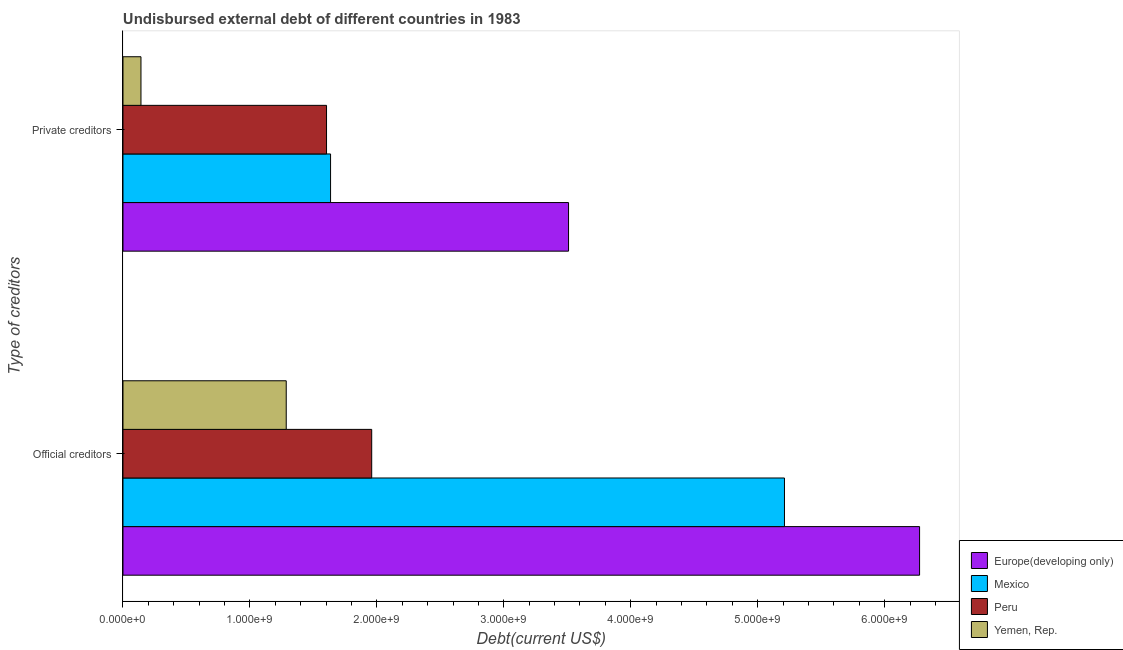What is the label of the 1st group of bars from the top?
Ensure brevity in your answer.  Private creditors. What is the undisbursed external debt of official creditors in Yemen, Rep.?
Offer a very short reply. 1.29e+09. Across all countries, what is the maximum undisbursed external debt of official creditors?
Make the answer very short. 6.28e+09. Across all countries, what is the minimum undisbursed external debt of official creditors?
Your response must be concise. 1.29e+09. In which country was the undisbursed external debt of private creditors maximum?
Your answer should be compact. Europe(developing only). In which country was the undisbursed external debt of private creditors minimum?
Give a very brief answer. Yemen, Rep. What is the total undisbursed external debt of official creditors in the graph?
Ensure brevity in your answer.  1.47e+1. What is the difference between the undisbursed external debt of private creditors in Mexico and that in Peru?
Your answer should be very brief. 3.18e+07. What is the difference between the undisbursed external debt of private creditors in Mexico and the undisbursed external debt of official creditors in Yemen, Rep.?
Give a very brief answer. 3.49e+08. What is the average undisbursed external debt of official creditors per country?
Offer a terse response. 3.68e+09. What is the difference between the undisbursed external debt of official creditors and undisbursed external debt of private creditors in Yemen, Rep.?
Your answer should be very brief. 1.14e+09. In how many countries, is the undisbursed external debt of official creditors greater than 5800000000 US$?
Provide a short and direct response. 1. What is the ratio of the undisbursed external debt of private creditors in Yemen, Rep. to that in Mexico?
Your answer should be very brief. 0.09. Is the undisbursed external debt of private creditors in Peru less than that in Mexico?
Provide a succinct answer. Yes. In how many countries, is the undisbursed external debt of official creditors greater than the average undisbursed external debt of official creditors taken over all countries?
Your answer should be compact. 2. What does the 4th bar from the top in Private creditors represents?
Offer a terse response. Europe(developing only). Are all the bars in the graph horizontal?
Your response must be concise. Yes. Are the values on the major ticks of X-axis written in scientific E-notation?
Provide a succinct answer. Yes. Does the graph contain any zero values?
Your answer should be compact. No. Where does the legend appear in the graph?
Offer a very short reply. Bottom right. How many legend labels are there?
Provide a short and direct response. 4. How are the legend labels stacked?
Provide a short and direct response. Vertical. What is the title of the graph?
Offer a terse response. Undisbursed external debt of different countries in 1983. Does "Bahamas" appear as one of the legend labels in the graph?
Offer a very short reply. No. What is the label or title of the X-axis?
Your answer should be compact. Debt(current US$). What is the label or title of the Y-axis?
Offer a very short reply. Type of creditors. What is the Debt(current US$) in Europe(developing only) in Official creditors?
Your answer should be compact. 6.28e+09. What is the Debt(current US$) in Mexico in Official creditors?
Offer a terse response. 5.21e+09. What is the Debt(current US$) in Peru in Official creditors?
Make the answer very short. 1.96e+09. What is the Debt(current US$) in Yemen, Rep. in Official creditors?
Your answer should be very brief. 1.29e+09. What is the Debt(current US$) of Europe(developing only) in Private creditors?
Your response must be concise. 3.51e+09. What is the Debt(current US$) of Mexico in Private creditors?
Your answer should be compact. 1.64e+09. What is the Debt(current US$) in Peru in Private creditors?
Offer a terse response. 1.60e+09. What is the Debt(current US$) of Yemen, Rep. in Private creditors?
Give a very brief answer. 1.42e+08. Across all Type of creditors, what is the maximum Debt(current US$) in Europe(developing only)?
Offer a very short reply. 6.28e+09. Across all Type of creditors, what is the maximum Debt(current US$) of Mexico?
Give a very brief answer. 5.21e+09. Across all Type of creditors, what is the maximum Debt(current US$) of Peru?
Make the answer very short. 1.96e+09. Across all Type of creditors, what is the maximum Debt(current US$) in Yemen, Rep.?
Ensure brevity in your answer.  1.29e+09. Across all Type of creditors, what is the minimum Debt(current US$) in Europe(developing only)?
Provide a succinct answer. 3.51e+09. Across all Type of creditors, what is the minimum Debt(current US$) of Mexico?
Provide a short and direct response. 1.64e+09. Across all Type of creditors, what is the minimum Debt(current US$) in Peru?
Provide a short and direct response. 1.60e+09. Across all Type of creditors, what is the minimum Debt(current US$) of Yemen, Rep.?
Ensure brevity in your answer.  1.42e+08. What is the total Debt(current US$) in Europe(developing only) in the graph?
Offer a terse response. 9.79e+09. What is the total Debt(current US$) in Mexico in the graph?
Provide a succinct answer. 6.85e+09. What is the total Debt(current US$) in Peru in the graph?
Keep it short and to the point. 3.56e+09. What is the total Debt(current US$) of Yemen, Rep. in the graph?
Provide a short and direct response. 1.43e+09. What is the difference between the Debt(current US$) in Europe(developing only) in Official creditors and that in Private creditors?
Provide a short and direct response. 2.77e+09. What is the difference between the Debt(current US$) in Mexico in Official creditors and that in Private creditors?
Your answer should be very brief. 3.58e+09. What is the difference between the Debt(current US$) of Peru in Official creditors and that in Private creditors?
Ensure brevity in your answer.  3.56e+08. What is the difference between the Debt(current US$) of Yemen, Rep. in Official creditors and that in Private creditors?
Ensure brevity in your answer.  1.14e+09. What is the difference between the Debt(current US$) in Europe(developing only) in Official creditors and the Debt(current US$) in Mexico in Private creditors?
Provide a succinct answer. 4.64e+09. What is the difference between the Debt(current US$) of Europe(developing only) in Official creditors and the Debt(current US$) of Peru in Private creditors?
Your response must be concise. 4.67e+09. What is the difference between the Debt(current US$) in Europe(developing only) in Official creditors and the Debt(current US$) in Yemen, Rep. in Private creditors?
Your answer should be very brief. 6.13e+09. What is the difference between the Debt(current US$) of Mexico in Official creditors and the Debt(current US$) of Peru in Private creditors?
Provide a short and direct response. 3.61e+09. What is the difference between the Debt(current US$) of Mexico in Official creditors and the Debt(current US$) of Yemen, Rep. in Private creditors?
Give a very brief answer. 5.07e+09. What is the difference between the Debt(current US$) in Peru in Official creditors and the Debt(current US$) in Yemen, Rep. in Private creditors?
Make the answer very short. 1.82e+09. What is the average Debt(current US$) in Europe(developing only) per Type of creditors?
Keep it short and to the point. 4.89e+09. What is the average Debt(current US$) in Mexico per Type of creditors?
Your response must be concise. 3.42e+09. What is the average Debt(current US$) of Peru per Type of creditors?
Give a very brief answer. 1.78e+09. What is the average Debt(current US$) in Yemen, Rep. per Type of creditors?
Your answer should be very brief. 7.14e+08. What is the difference between the Debt(current US$) of Europe(developing only) and Debt(current US$) of Mexico in Official creditors?
Make the answer very short. 1.06e+09. What is the difference between the Debt(current US$) of Europe(developing only) and Debt(current US$) of Peru in Official creditors?
Your answer should be compact. 4.32e+09. What is the difference between the Debt(current US$) of Europe(developing only) and Debt(current US$) of Yemen, Rep. in Official creditors?
Offer a terse response. 4.99e+09. What is the difference between the Debt(current US$) of Mexico and Debt(current US$) of Peru in Official creditors?
Provide a succinct answer. 3.25e+09. What is the difference between the Debt(current US$) of Mexico and Debt(current US$) of Yemen, Rep. in Official creditors?
Your answer should be compact. 3.93e+09. What is the difference between the Debt(current US$) in Peru and Debt(current US$) in Yemen, Rep. in Official creditors?
Your answer should be compact. 6.73e+08. What is the difference between the Debt(current US$) in Europe(developing only) and Debt(current US$) in Mexico in Private creditors?
Your answer should be compact. 1.87e+09. What is the difference between the Debt(current US$) in Europe(developing only) and Debt(current US$) in Peru in Private creditors?
Give a very brief answer. 1.91e+09. What is the difference between the Debt(current US$) of Europe(developing only) and Debt(current US$) of Yemen, Rep. in Private creditors?
Keep it short and to the point. 3.37e+09. What is the difference between the Debt(current US$) of Mexico and Debt(current US$) of Peru in Private creditors?
Your answer should be compact. 3.18e+07. What is the difference between the Debt(current US$) in Mexico and Debt(current US$) in Yemen, Rep. in Private creditors?
Provide a succinct answer. 1.49e+09. What is the difference between the Debt(current US$) of Peru and Debt(current US$) of Yemen, Rep. in Private creditors?
Provide a succinct answer. 1.46e+09. What is the ratio of the Debt(current US$) of Europe(developing only) in Official creditors to that in Private creditors?
Make the answer very short. 1.79. What is the ratio of the Debt(current US$) in Mexico in Official creditors to that in Private creditors?
Provide a succinct answer. 3.19. What is the ratio of the Debt(current US$) of Peru in Official creditors to that in Private creditors?
Your answer should be compact. 1.22. What is the ratio of the Debt(current US$) in Yemen, Rep. in Official creditors to that in Private creditors?
Ensure brevity in your answer.  9.07. What is the difference between the highest and the second highest Debt(current US$) in Europe(developing only)?
Keep it short and to the point. 2.77e+09. What is the difference between the highest and the second highest Debt(current US$) of Mexico?
Give a very brief answer. 3.58e+09. What is the difference between the highest and the second highest Debt(current US$) of Peru?
Provide a succinct answer. 3.56e+08. What is the difference between the highest and the second highest Debt(current US$) of Yemen, Rep.?
Your answer should be very brief. 1.14e+09. What is the difference between the highest and the lowest Debt(current US$) of Europe(developing only)?
Ensure brevity in your answer.  2.77e+09. What is the difference between the highest and the lowest Debt(current US$) of Mexico?
Keep it short and to the point. 3.58e+09. What is the difference between the highest and the lowest Debt(current US$) of Peru?
Offer a very short reply. 3.56e+08. What is the difference between the highest and the lowest Debt(current US$) in Yemen, Rep.?
Provide a short and direct response. 1.14e+09. 